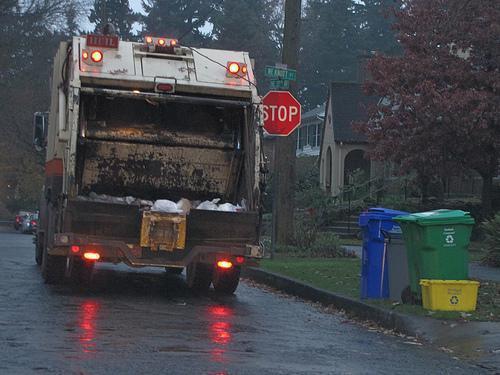How many of the garbage bins are green?
Give a very brief answer. 1. How many blue trash bins are there?
Give a very brief answer. 1. How many blue trash cans are there?
Give a very brief answer. 1. 